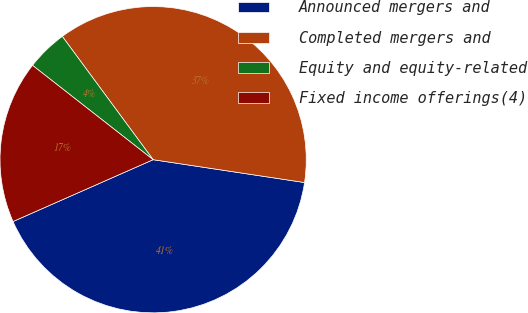Convert chart. <chart><loc_0><loc_0><loc_500><loc_500><pie_chart><fcel>Announced mergers and<fcel>Completed mergers and<fcel>Equity and equity-related<fcel>Fixed income offerings(4)<nl><fcel>41.0%<fcel>37.49%<fcel>4.33%<fcel>17.18%<nl></chart> 